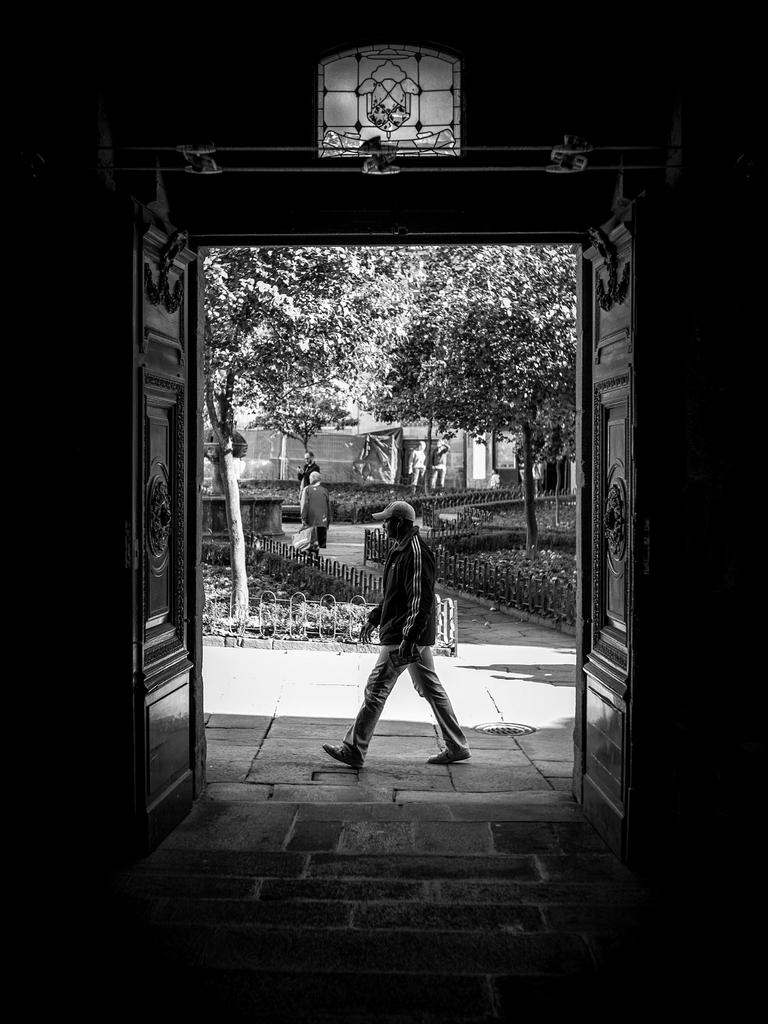What type of structures can be seen in the image? There are doors in the image. What is the person in the image doing? There is a person walking in the image. What type of barrier is present in the image? There is a fence in the image. What type of vegetation is visible in the image? There are trees in the image. Can you see a needle threading through the fence in the image? There is no needle or threading activity present in the image. Is there a boat sailing through the trees in the image? There is no boat or sailing activity present in the image. 